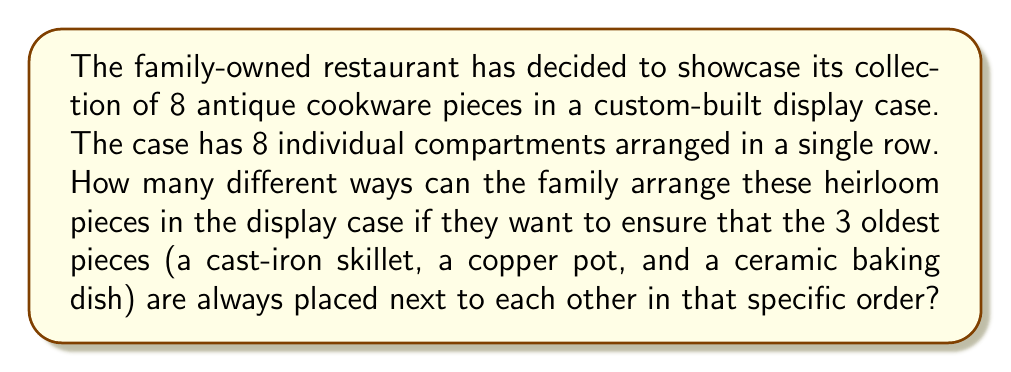Help me with this question. Let's approach this step-by-step:

1) First, we can consider the 3 oldest pieces (cast-iron skillet, copper pot, and ceramic baking dish) as one unit. This is because they must always be placed together in that specific order.

2) Now, we essentially have 6 items to arrange:
   - The unit of 3 oldest pieces
   - The other 5 individual cookware pieces

3) To calculate the number of permutations for 6 items, we use the factorial formula:

   $$ 6! = 6 \times 5 \times 4 \times 3 \times 2 \times 1 = 720 $$

4) However, we're not done yet. For each of these 720 arrangements, the 3 oldest pieces within their unit can also be arranged in the display case in 6 different ways:
   - At the very left (1 way)
   - Between any two of the other 5 pieces (4 ways)
   - At the very right (1 way)

5) Therefore, we need to multiply our initial result by 6:

   $$ 720 \times 6 = 4,320 $$

Thus, there are 4,320 different ways to arrange the cookware pieces in the display case while keeping the 3 oldest pieces together in their specific order.
Answer: 4,320 ways 